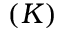Convert formula to latex. <formula><loc_0><loc_0><loc_500><loc_500>( K )</formula> 